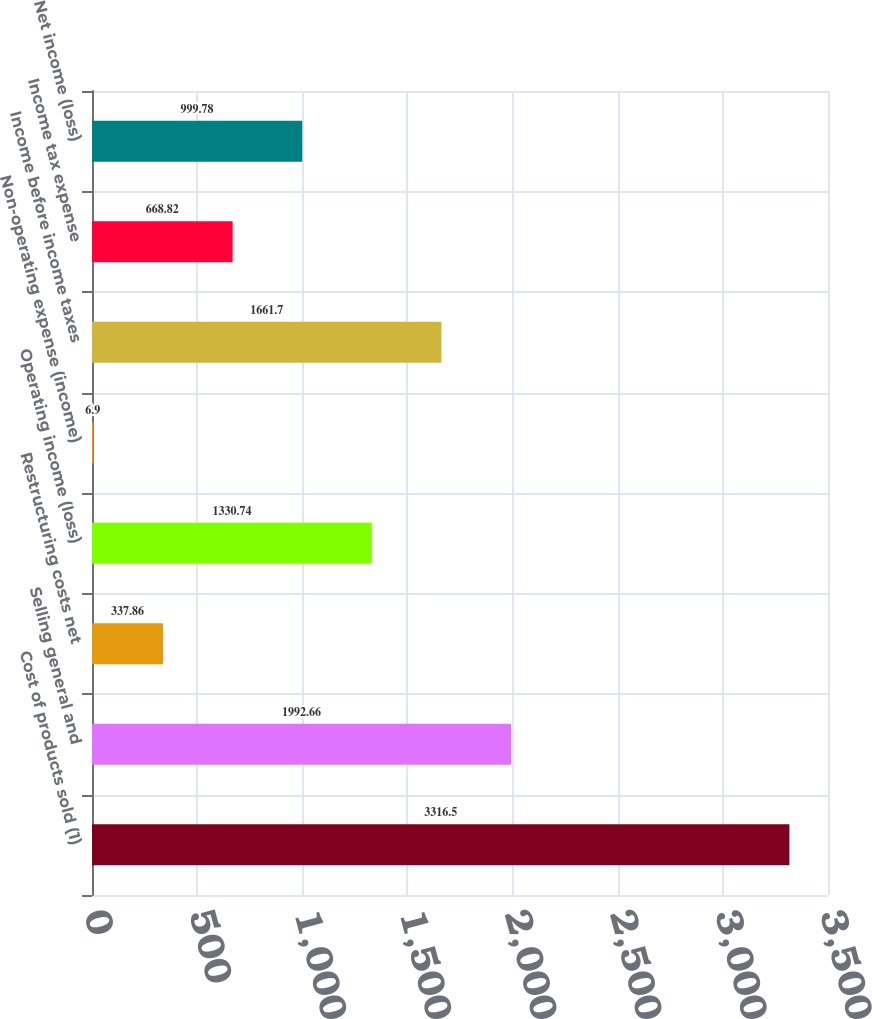Convert chart to OTSL. <chart><loc_0><loc_0><loc_500><loc_500><bar_chart><fcel>Cost of products sold (1)<fcel>Selling general and<fcel>Restructuring costs net<fcel>Operating income (loss)<fcel>Non-operating expense (income)<fcel>Income before income taxes<fcel>Income tax expense<fcel>Net income (loss)<nl><fcel>3316.5<fcel>1992.66<fcel>337.86<fcel>1330.74<fcel>6.9<fcel>1661.7<fcel>668.82<fcel>999.78<nl></chart> 